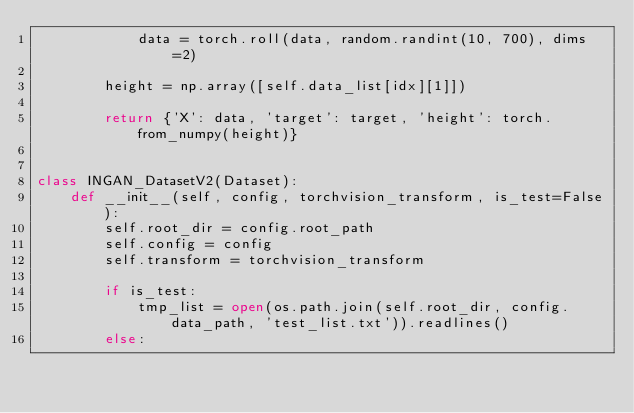Convert code to text. <code><loc_0><loc_0><loc_500><loc_500><_Python_>            data = torch.roll(data, random.randint(10, 700), dims=2)

        height = np.array([self.data_list[idx][1]])
        
        return {'X': data, 'target': target, 'height': torch.from_numpy(height)}


class INGAN_DatasetV2(Dataset):
    def __init__(self, config, torchvision_transform, is_test=False):
        self.root_dir = config.root_path
        self.config = config
        self.transform = torchvision_transform

        if is_test:
            tmp_list = open(os.path.join(self.root_dir, config.data_path, 'test_list.txt')).readlines()
        else:</code> 